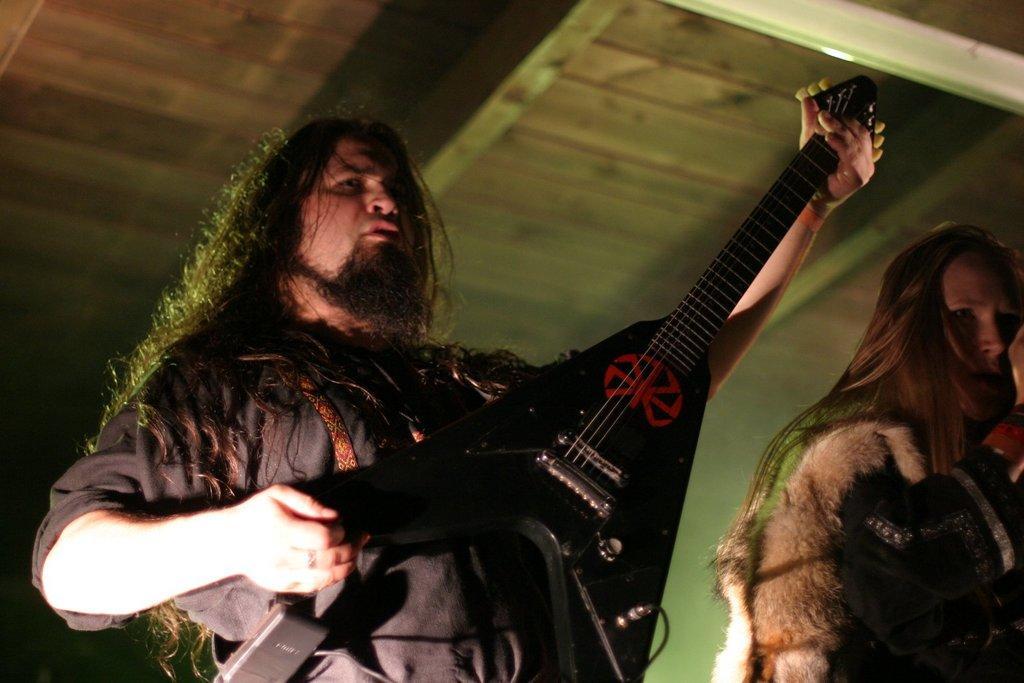Could you give a brief overview of what you see in this image? This picture shows a man playing a guitar in his hands. Beside him there is a woman standing. In the background there is a roof. 